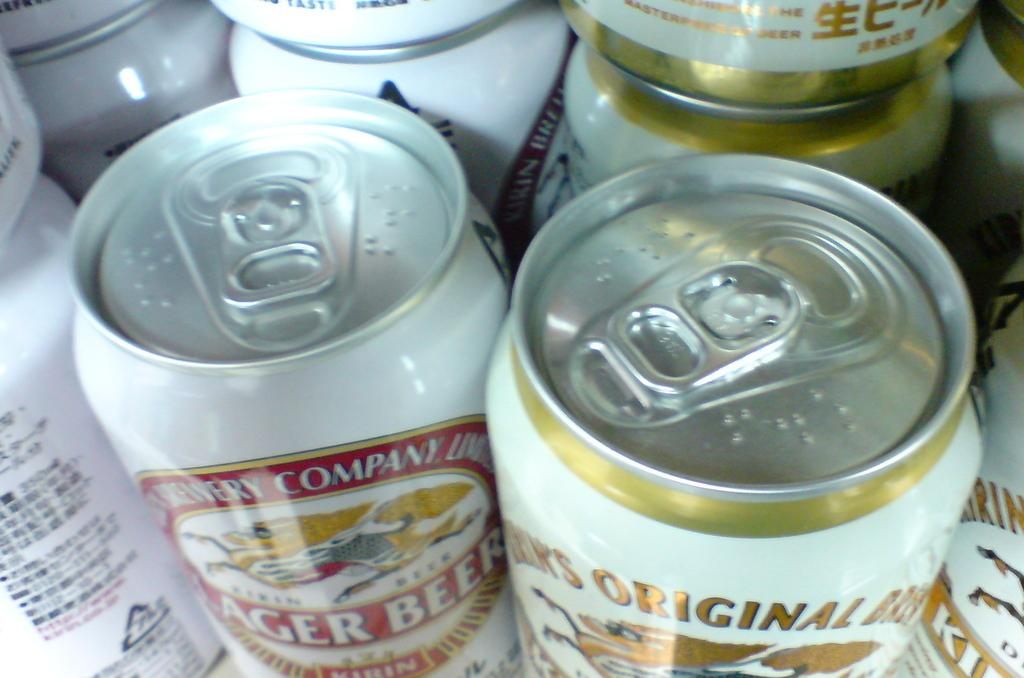What type of containers are present in the image? There are cool-drink tins in the image. What color are the cool-drink tins? The cool-drink tins are white in color. Is there any text or design on the cool-drink tins? Yes, there is something printed on the cool-drink tins. How many hens are sitting on the cool-drink tins in the image? There are no hens present in the image. 